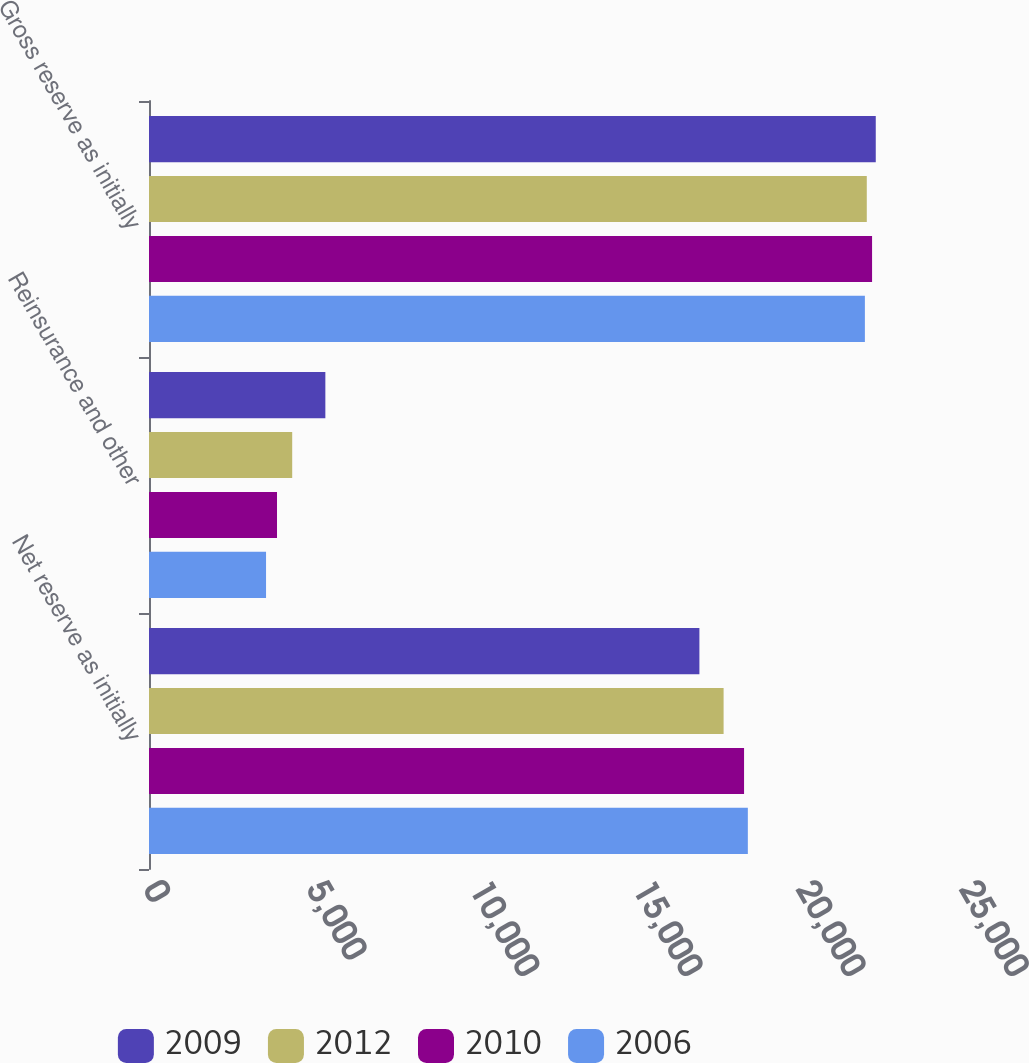Convert chart. <chart><loc_0><loc_0><loc_500><loc_500><stacked_bar_chart><ecel><fcel>Net reserve as initially<fcel>Reinsurance and other<fcel>Gross reserve as initially<nl><fcel>2009<fcel>16863<fcel>5403<fcel>22266<nl><fcel>2012<fcel>17604<fcel>4387<fcel>21991<nl><fcel>2010<fcel>18231<fcel>3922<fcel>22153<nl><fcel>2006<fcel>18347<fcel>3586<fcel>21933<nl></chart> 